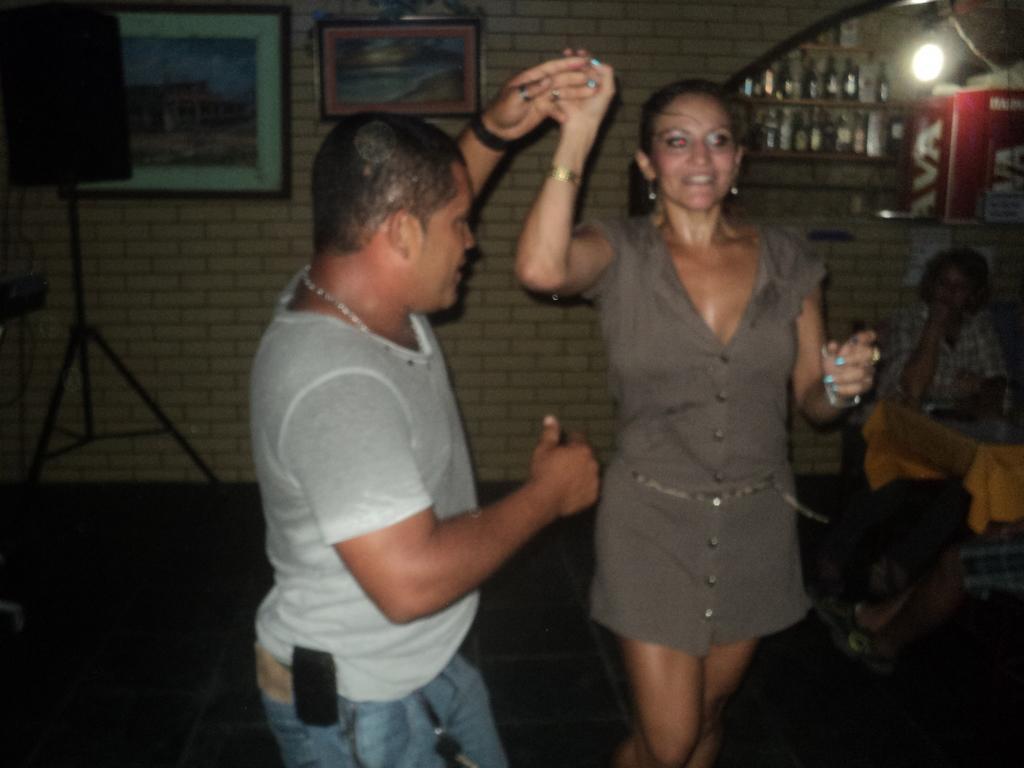Describe this image in one or two sentences. On the left side, there is a person in white color t-shirt, holding a hand of a woman who is smiling and dancing on the floor. In the background, there is a person sitting, there are bottles arranged on the shelves, there is a light, there are photo frames attached to the wall and there is a speaker on a stand. 